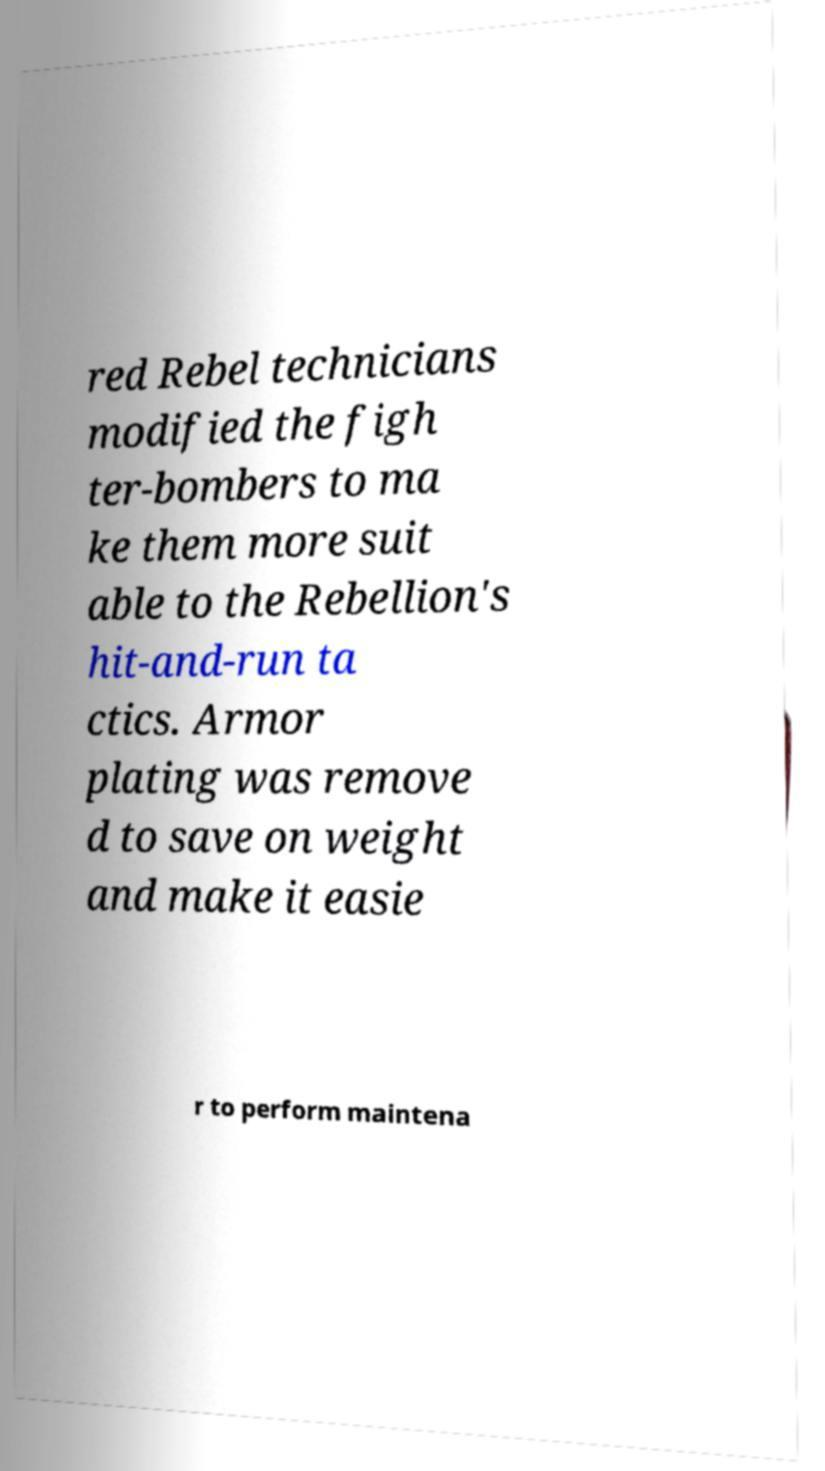Could you assist in decoding the text presented in this image and type it out clearly? red Rebel technicians modified the figh ter-bombers to ma ke them more suit able to the Rebellion's hit-and-run ta ctics. Armor plating was remove d to save on weight and make it easie r to perform maintena 